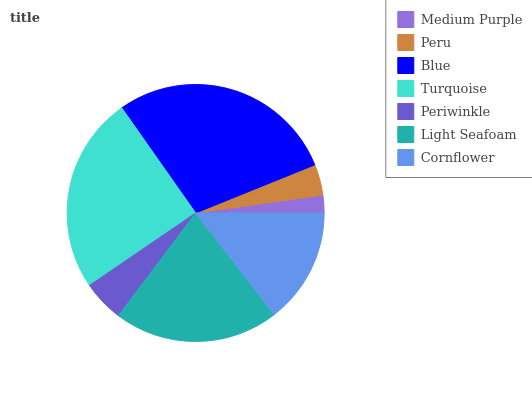Is Medium Purple the minimum?
Answer yes or no. Yes. Is Blue the maximum?
Answer yes or no. Yes. Is Peru the minimum?
Answer yes or no. No. Is Peru the maximum?
Answer yes or no. No. Is Peru greater than Medium Purple?
Answer yes or no. Yes. Is Medium Purple less than Peru?
Answer yes or no. Yes. Is Medium Purple greater than Peru?
Answer yes or no. No. Is Peru less than Medium Purple?
Answer yes or no. No. Is Cornflower the high median?
Answer yes or no. Yes. Is Cornflower the low median?
Answer yes or no. Yes. Is Periwinkle the high median?
Answer yes or no. No. Is Light Seafoam the low median?
Answer yes or no. No. 